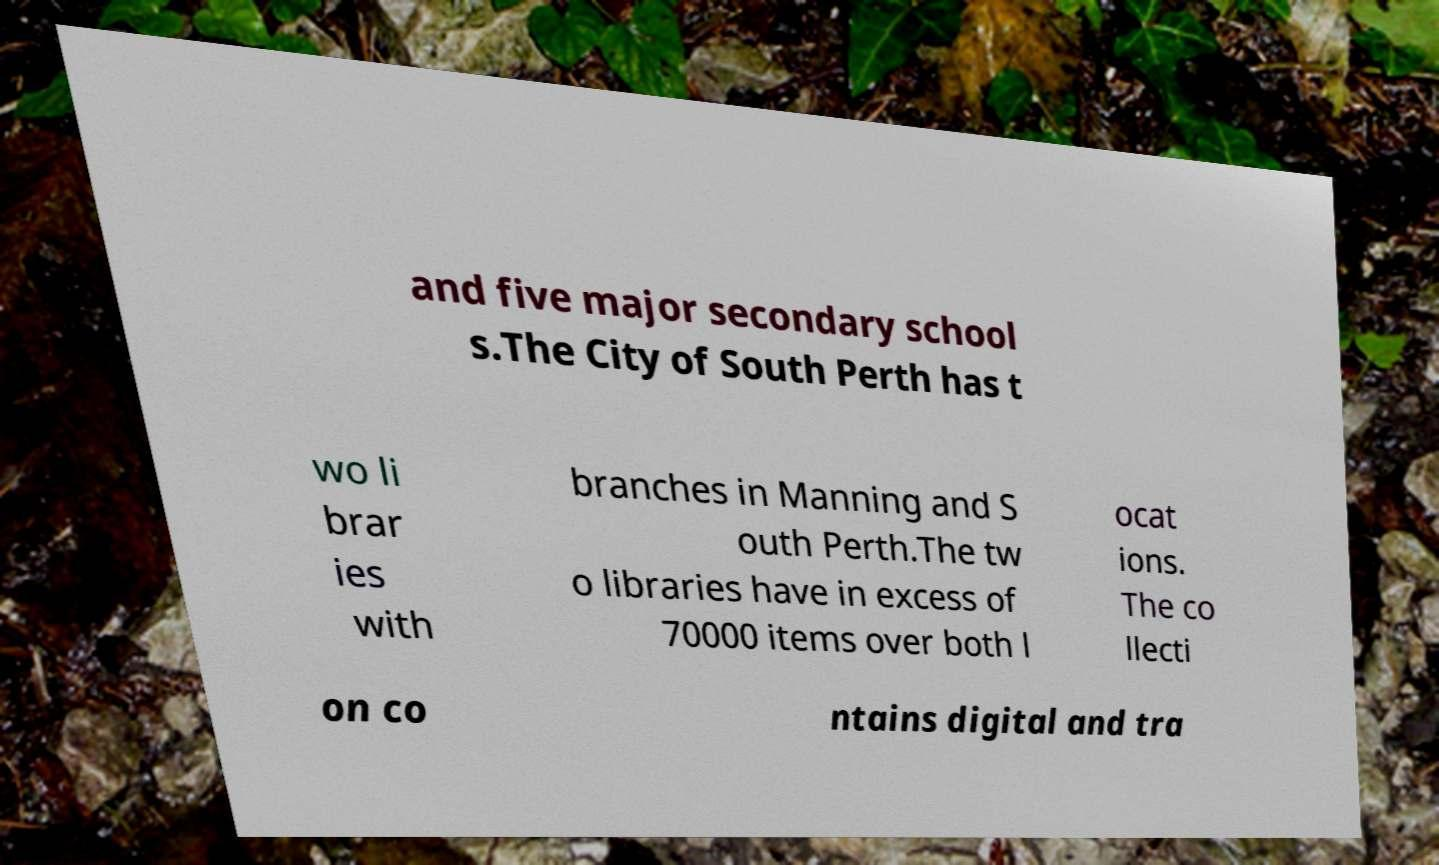Can you read and provide the text displayed in the image?This photo seems to have some interesting text. Can you extract and type it out for me? and five major secondary school s.The City of South Perth has t wo li brar ies with branches in Manning and S outh Perth.The tw o libraries have in excess of 70000 items over both l ocat ions. The co llecti on co ntains digital and tra 